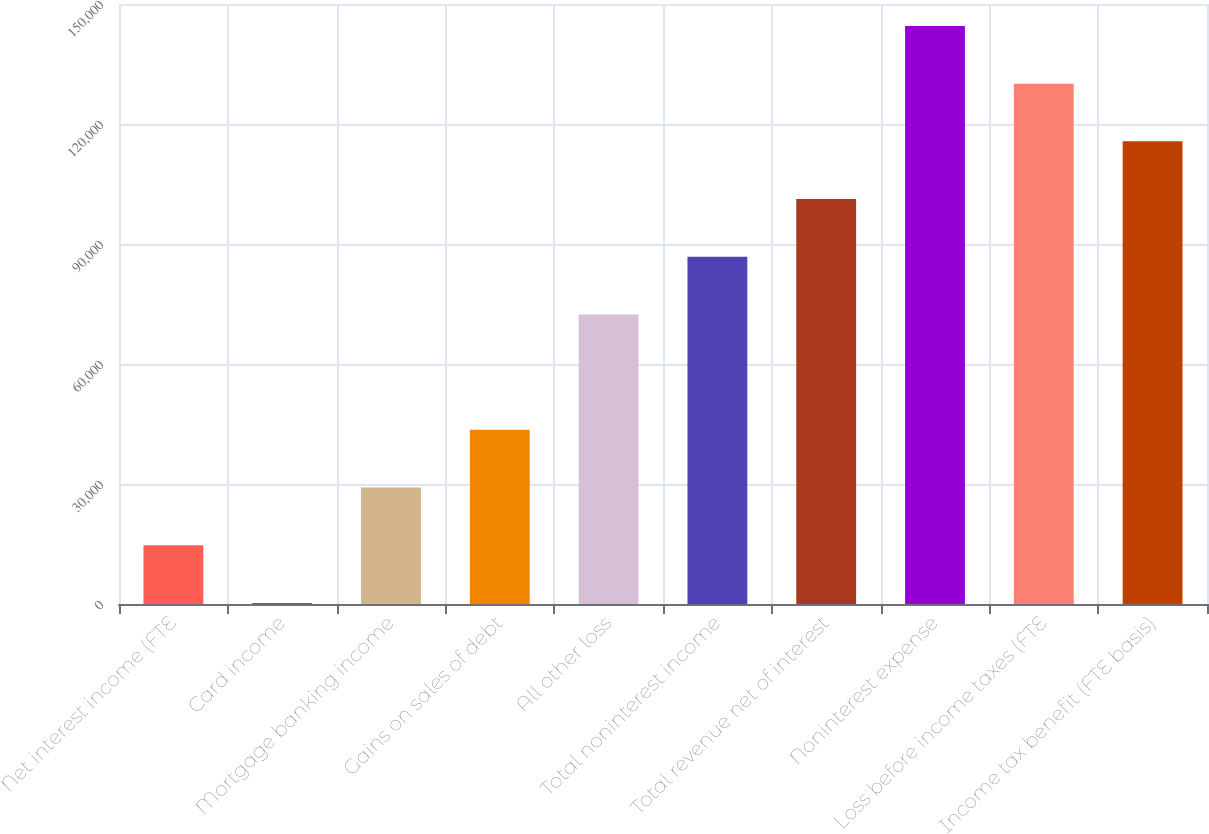Convert chart to OTSL. <chart><loc_0><loc_0><loc_500><loc_500><bar_chart><fcel>Net interest income (FTE<fcel>Card income<fcel>Mortgage banking income<fcel>Gains on sales of debt<fcel>All other loss<fcel>Total noninterest income<fcel>Total revenue net of interest<fcel>Noninterest expense<fcel>Loss before income taxes (FTE<fcel>Income tax benefit (FTE basis)<nl><fcel>14684.6<fcel>260<fcel>29109.2<fcel>43533.8<fcel>72383<fcel>86807.6<fcel>101232<fcel>144506<fcel>130081<fcel>115657<nl></chart> 